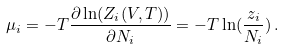Convert formula to latex. <formula><loc_0><loc_0><loc_500><loc_500>\mu _ { i } = - T \frac { \partial \ln ( Z _ { i } ( V , T ) ) } { \partial N _ { i } } = - T \ln ( \frac { z _ { i } } { N _ { i } } ) \, .</formula> 